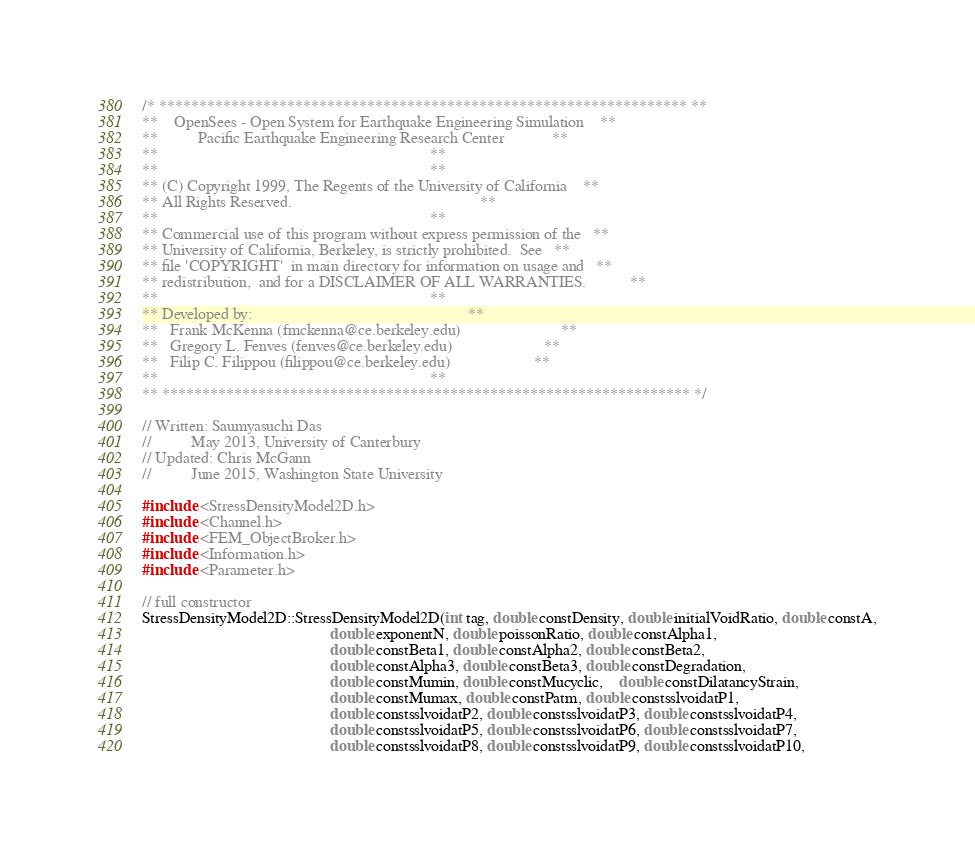Convert code to text. <code><loc_0><loc_0><loc_500><loc_500><_C++_>/* ****************************************************************** **
**    OpenSees - Open System for Earthquake Engineering Simulation    **
**          Pacific Earthquake Engineering Research Center            **
**                                                                    **
**                                                                    **
** (C) Copyright 1999, The Regents of the University of California    **
** All Rights Reserved.                                               **
**                                                                    **
** Commercial use of this program without express permission of the   **
** University of California, Berkeley, is strictly prohibited.  See   **
** file 'COPYRIGHT'  in main directory for information on usage and   **
** redistribution,  and for a DISCLAIMER OF ALL WARRANTIES.           **
**                                                                    **
** Developed by:                                                      **
**   Frank McKenna (fmckenna@ce.berkeley.edu)                         **
**   Gregory L. Fenves (fenves@ce.berkeley.edu)                       **
**   Filip C. Filippou (filippou@ce.berkeley.edu)                     **
**                                                                    **
** ****************************************************************** */

// Written: Saumyasuchi Das
//          May 2013, University of Canterbury
// Updated: Chris McGann
//          June 2015, Washington State University

#include <StressDensityModel2D.h>
#include <Channel.h>
#include <FEM_ObjectBroker.h>
#include <Information.h>
#include <Parameter.h>

// full constructor
StressDensityModel2D::StressDensityModel2D(int tag, double constDensity, double initialVoidRatio, double constA,
                                               double exponentN, double poissonRatio, double constAlpha1, 
                                               double constBeta1, double constAlpha2, double constBeta2, 
                                               double constAlpha3, double constBeta3, double constDegradation,
                                               double constMumin, double constMucyclic,	double constDilatancyStrain,
                                               double constMumax, double constPatm, double constsslvoidatP1,
                                               double constsslvoidatP2, double constsslvoidatP3, double constsslvoidatP4,
                                               double constsslvoidatP5, double constsslvoidatP6, double constsslvoidatP7,
                                               double constsslvoidatP8, double constsslvoidatP9, double constsslvoidatP10,</code> 